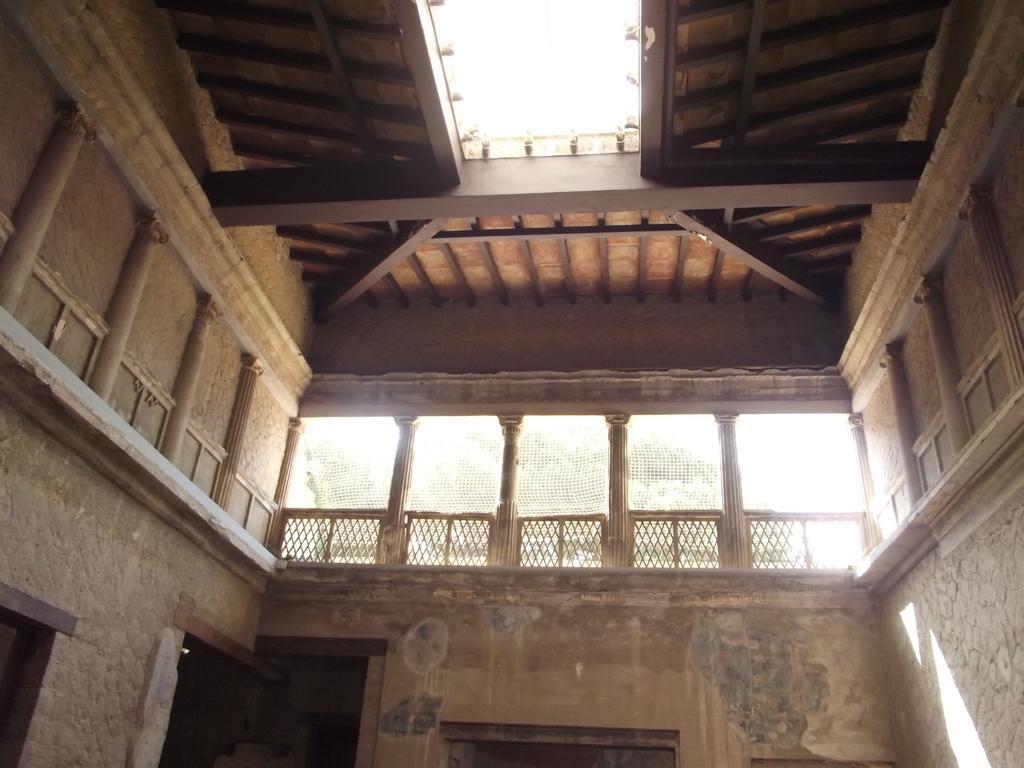Can you describe this image briefly? This image is clicked inside the house. In the center there is a railing, there are doors to the walls. At the top there is ceiling and we can see some trees outside of the house. 